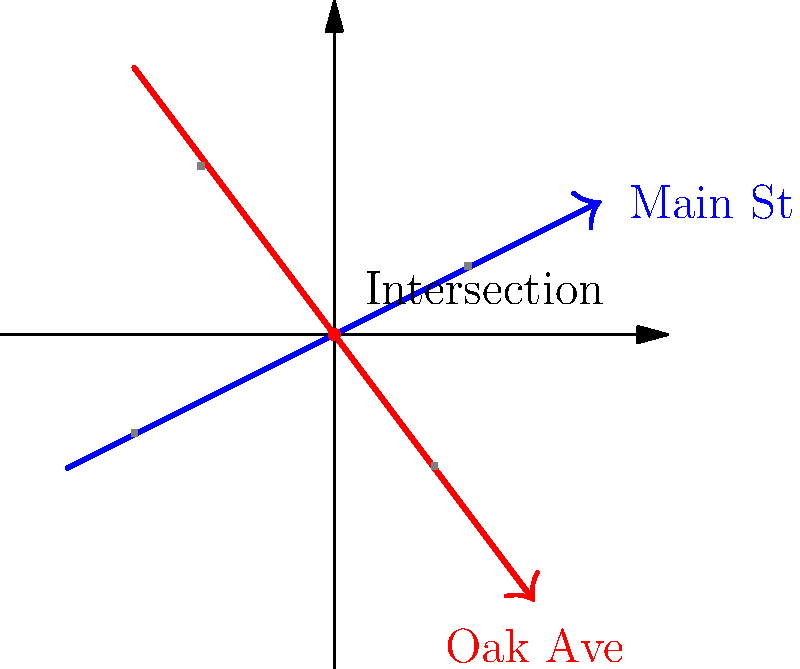At the intersection of Main Street and Oak Avenue, traffic flow can be represented by two lines: $y = \frac{1}{2}x$ for Main Street and $y = -\frac{4}{3}x$ for Oak Avenue. A traffic accident occurred at the intersection point. What are the coordinates of this accident location? To find the intersection point of the two lines, we need to solve the system of equations:

1) Main Street: $y = \frac{1}{2}x$
2) Oak Avenue: $y = -\frac{4}{3}x$

At the intersection point, the $y$ values are equal, so:

$$\frac{1}{2}x = -\frac{4}{3}x$$

Multiply both sides by 6 to eliminate fractions:

$$3x = -8x$$

Add 8x to both sides:

$$11x = 0$$

Divide by 11:

$$x = 0$$

Now, substitute this $x$ value into either of the original equations. Let's use Main Street's equation:

$$y = \frac{1}{2}(0) = 0$$

Therefore, the intersection point (and location of the accident) is at $(0, 0)$.
Answer: $(0, 0)$ 